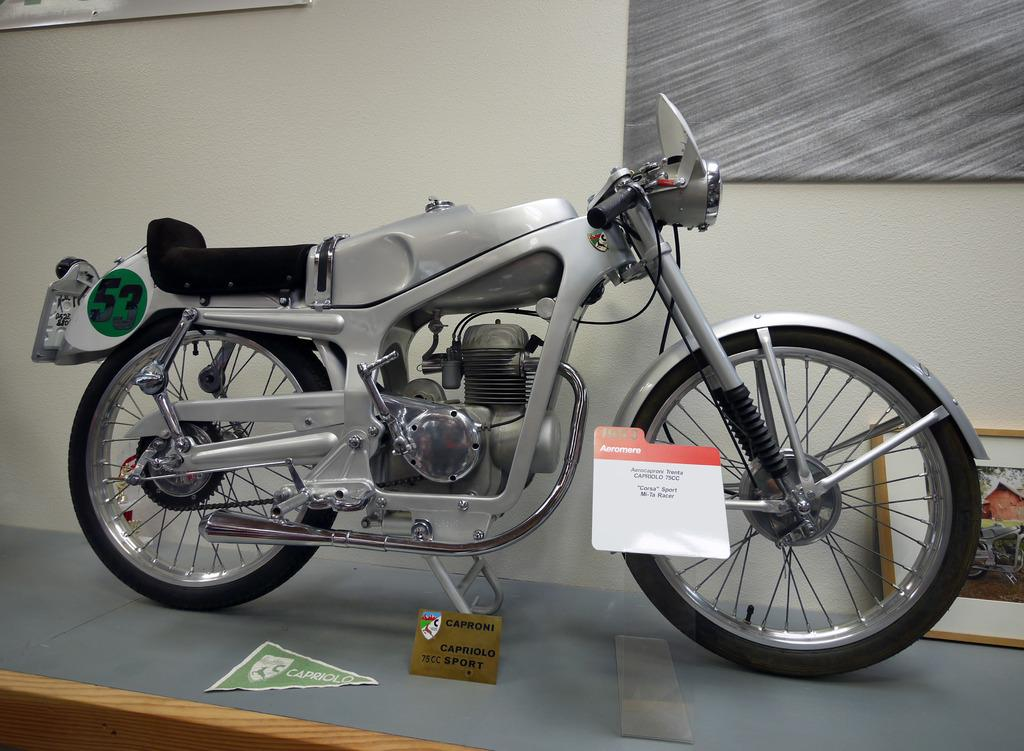What color is the bike in the image? The bike in the image is silver in color. Where is the bike located in the image? The bike is standing on a table top in the image. What can be seen in the background of the image? There is a white color wall and a grey color fabric frame in the background of the image. How does the parent help the bike in the image? There is no parent present in the image, and therefore no help can be provided to the bike. 